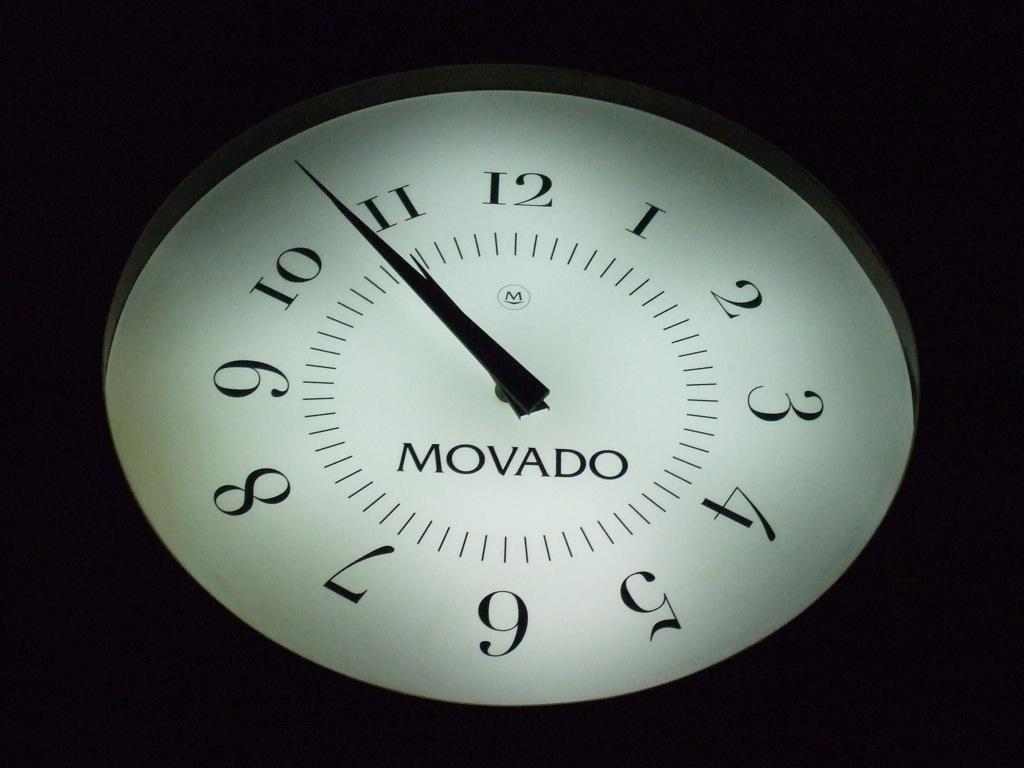<image>
Summarize the visual content of the image. a clock that has the word Movado on it 